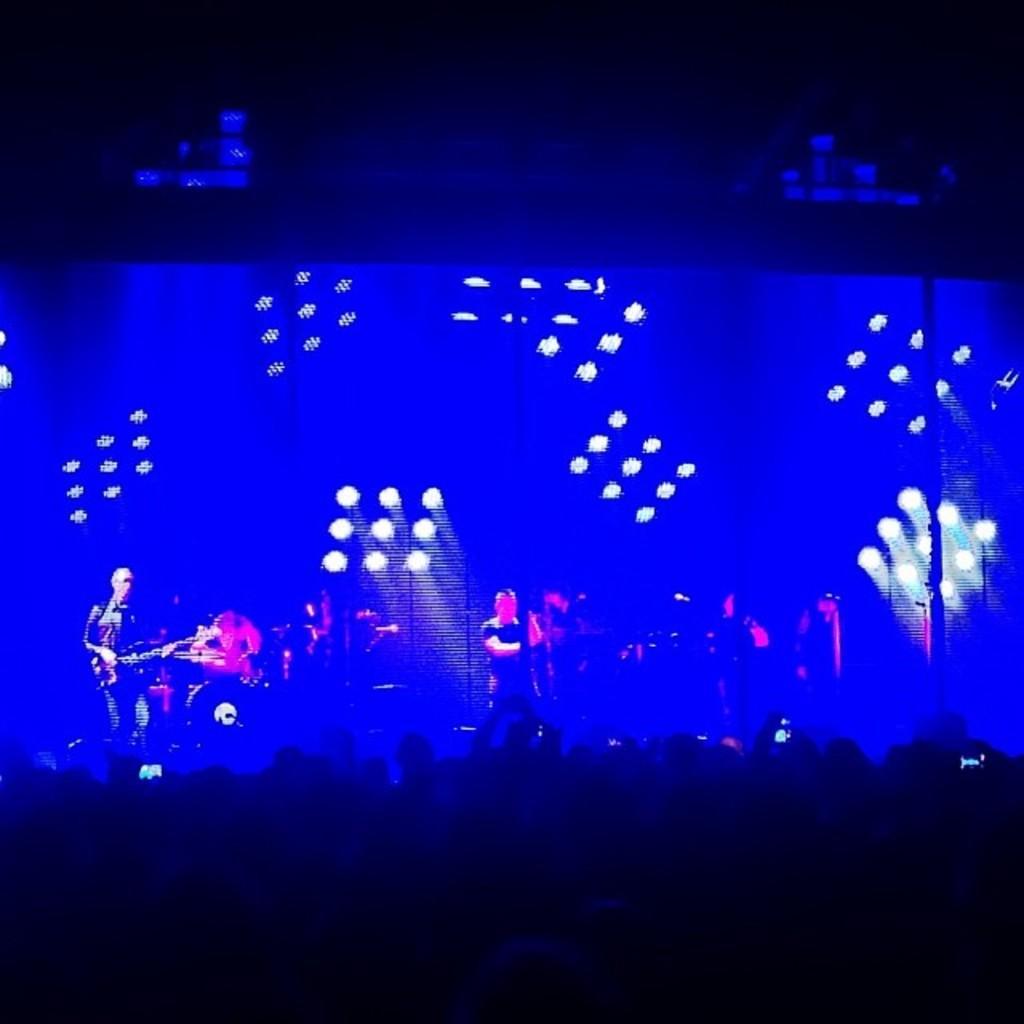In one or two sentences, can you explain what this image depicts? In the image we can see there are people wearing clothes. Here we can see disco lights and musical instruments. The top and the bottom of the image is dark. 